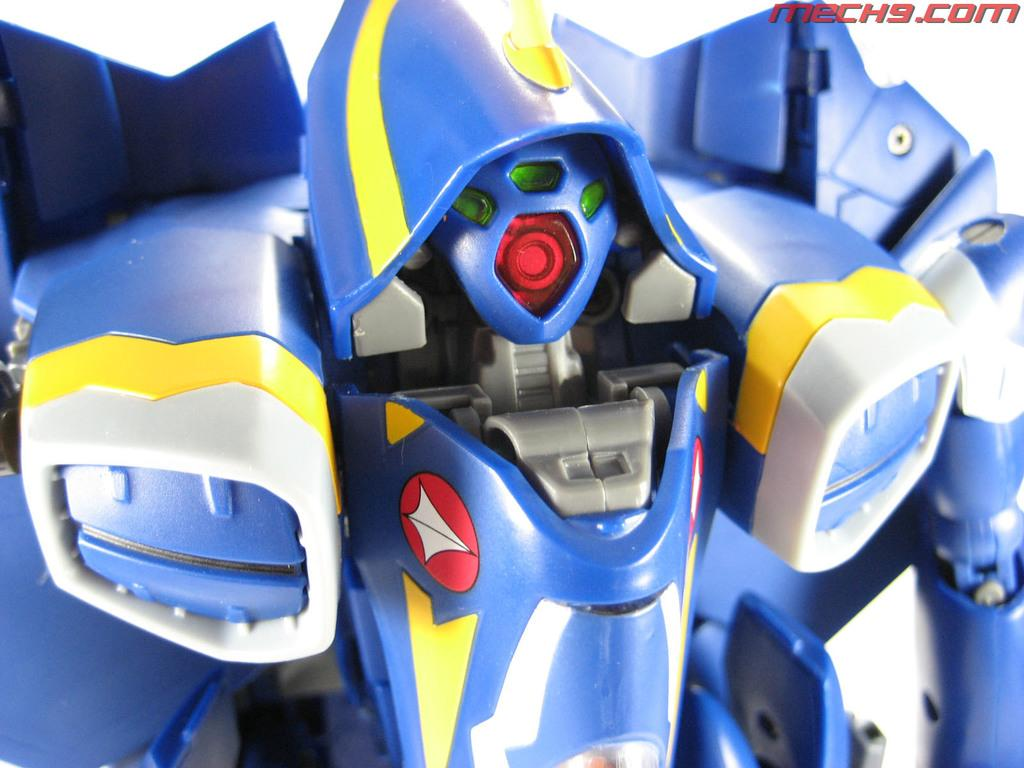What object is the main focus of the image? There is a toy robot in the image. Can you describe the appearance of the toy robot? The toy robot is blue in color. What type of breakfast is the toy robot eating in the image? There is no breakfast present in the image, as it features a toy robot that is not capable of eating. 